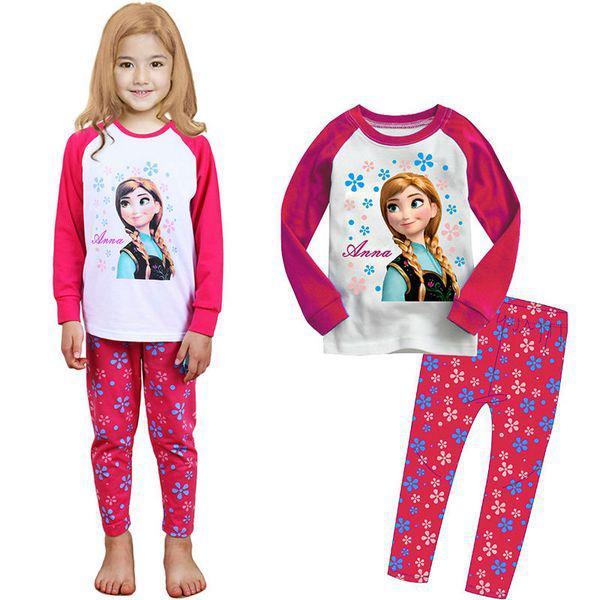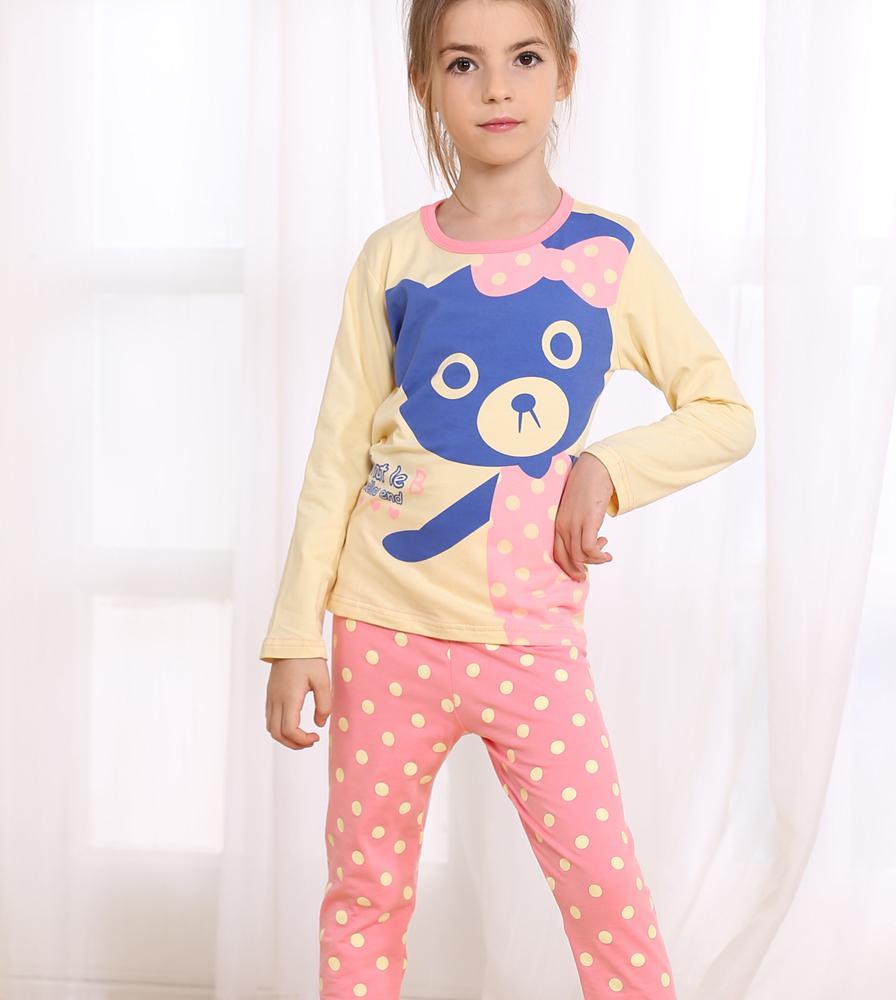The first image is the image on the left, the second image is the image on the right. Considering the images on both sides, is "There are more kids in the image on the right than in the image on the left." valid? Answer yes or no. No. The first image is the image on the left, the second image is the image on the right. Given the left and right images, does the statement "One image shows two sleepwear outfits that feature the face of a Disney princess-type character on the front." hold true? Answer yes or no. Yes. 